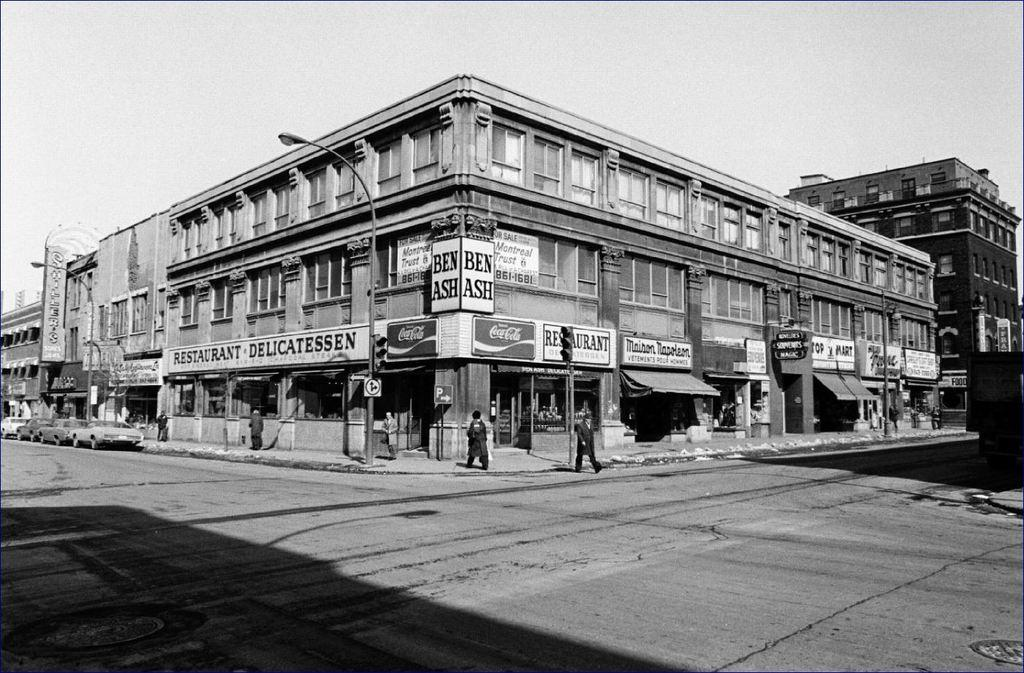<image>
Create a compact narrative representing the image presented. Ben Ash restaurant and delicatessen is on the corner. 